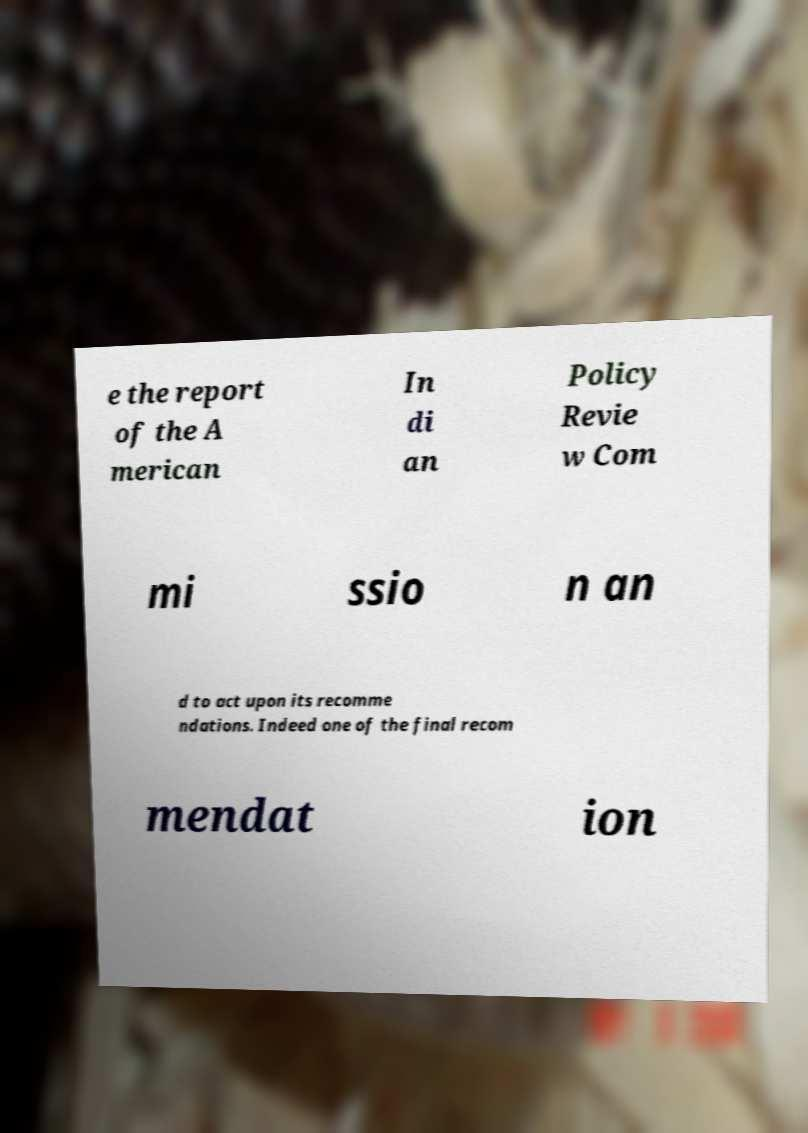What messages or text are displayed in this image? I need them in a readable, typed format. e the report of the A merican In di an Policy Revie w Com mi ssio n an d to act upon its recomme ndations. Indeed one of the final recom mendat ion 